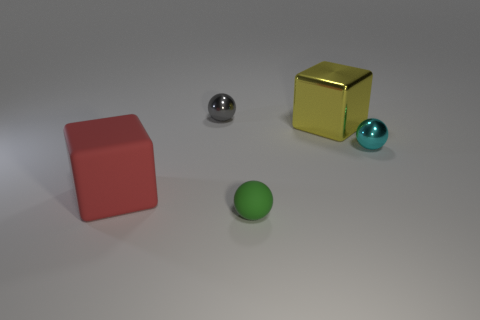How do the different textures of the objects in the image affect the overall aesthetic? The contrast in textures among the smooth sphere, the shinier metallic sphere, the matte cube, and the reflective golden cube creates a dynamic visual composition. This interplay of textures adds depth to the scene and highlights the unique surface qualities of each item. 